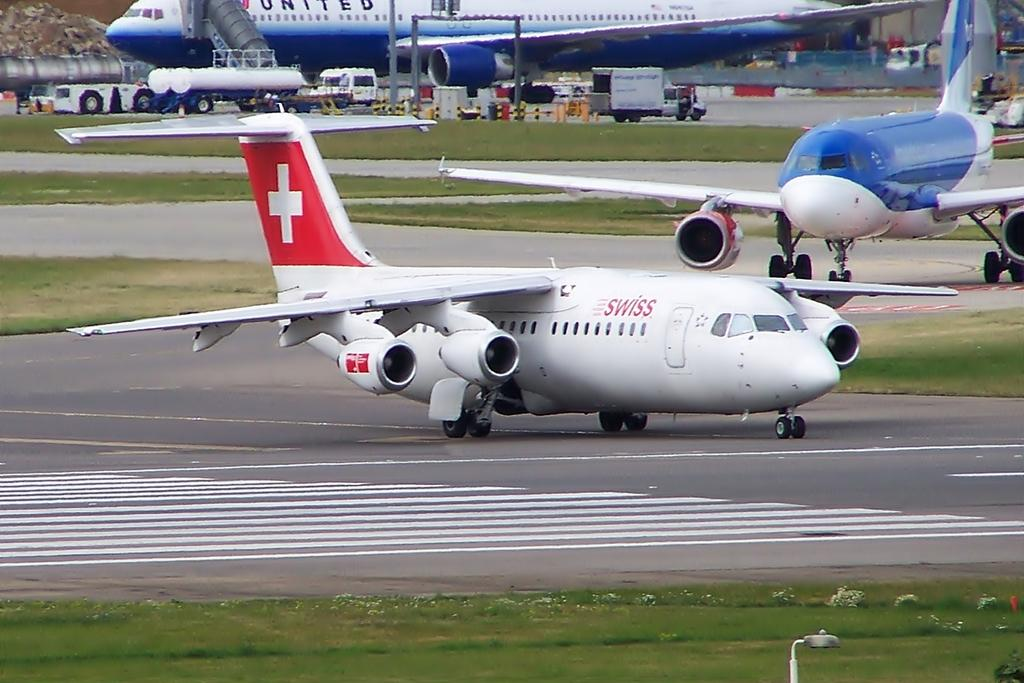<image>
Render a clear and concise summary of the photo. A SWISS airlines passanger aeroplane on the runway 